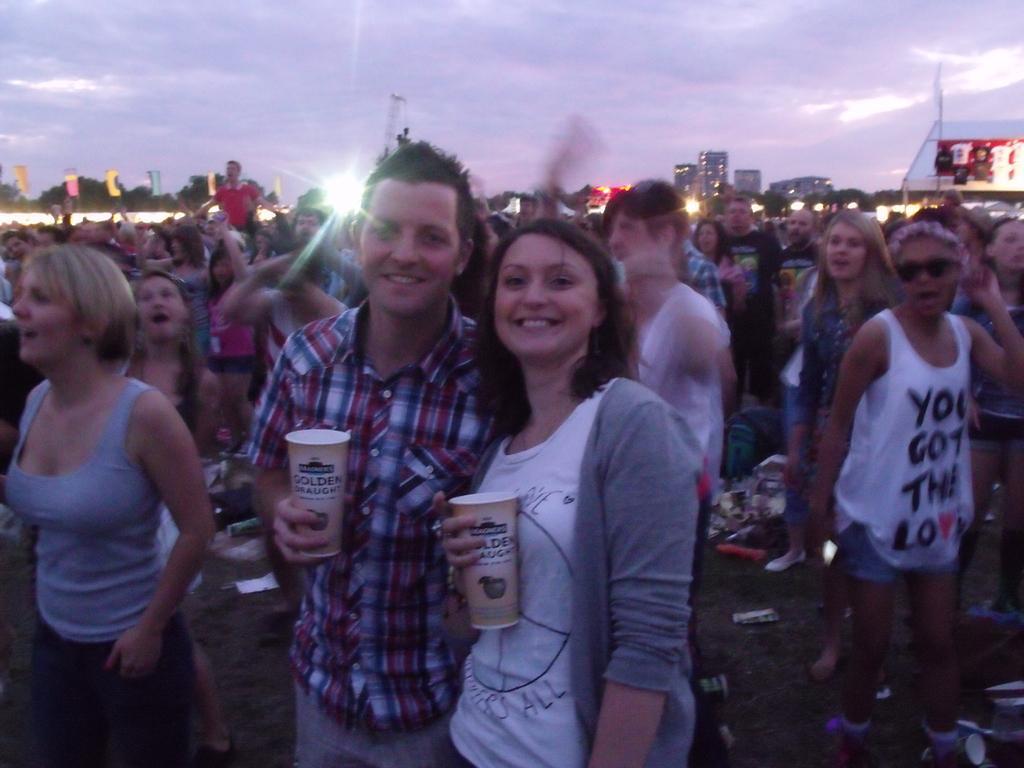Can you describe this image briefly? In this image, we can see a group of people are standing on the ground. Here we can see woman and man are holding a glasses. They are watching and smiling. Background we can see trees, buildings, hoarding and sky. 